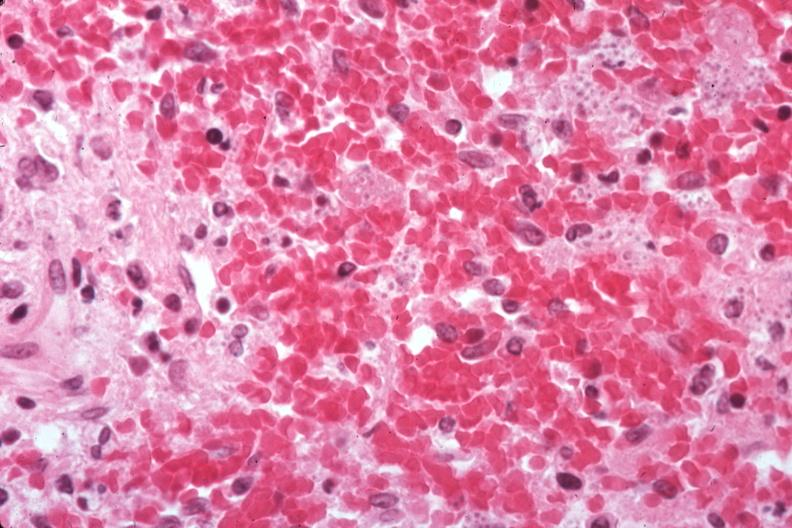s spleen present?
Answer the question using a single word or phrase. Yes 